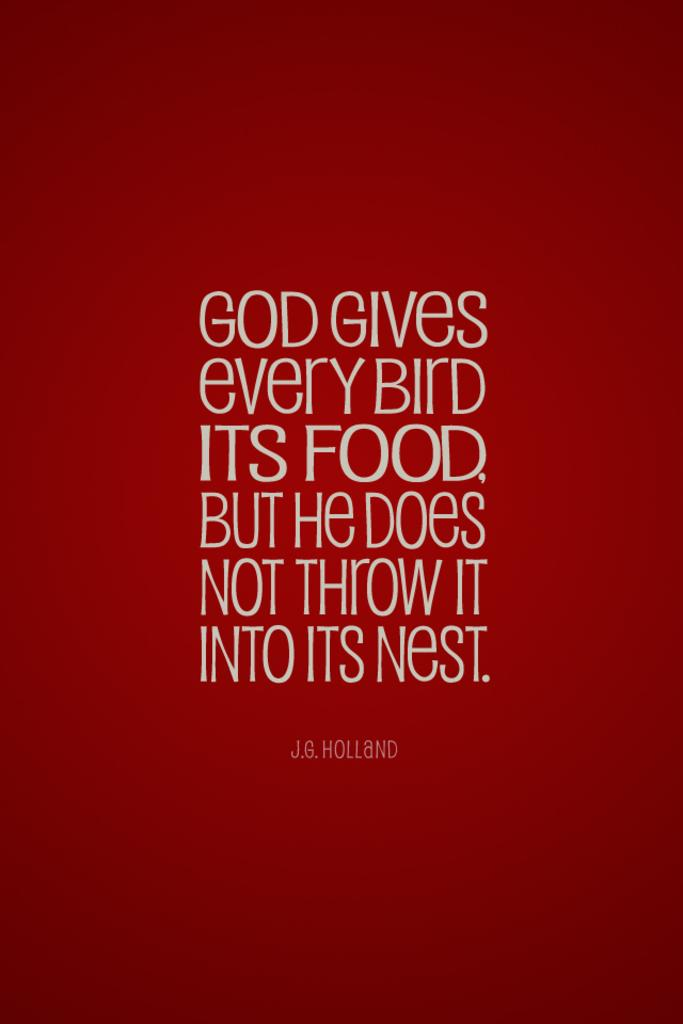<image>
Give a short and clear explanation of the subsequent image. a red graphic with text saying 'god gives every bird its food, but he does not throw it into its nest.' 